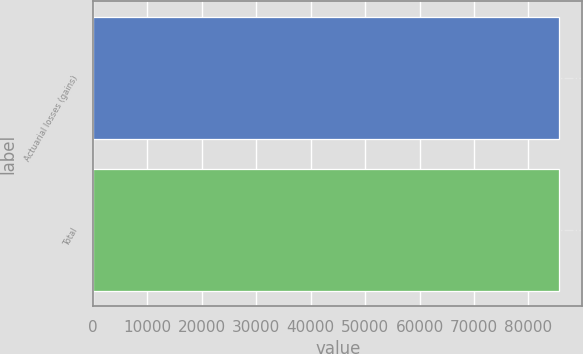Convert chart to OTSL. <chart><loc_0><loc_0><loc_500><loc_500><bar_chart><fcel>Actuarial losses (gains)<fcel>Total<nl><fcel>85636<fcel>85636.1<nl></chart> 